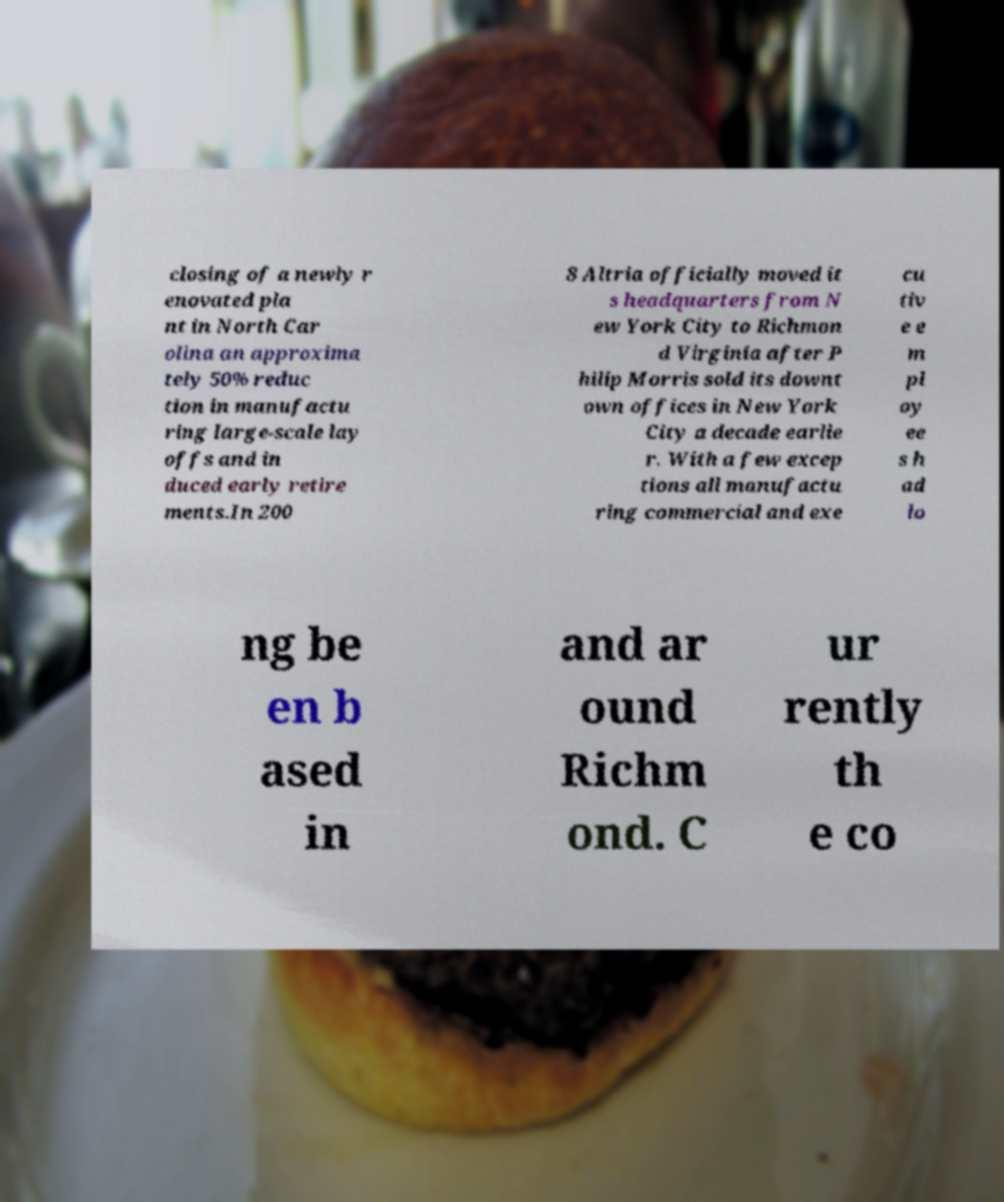What messages or text are displayed in this image? I need them in a readable, typed format. closing of a newly r enovated pla nt in North Car olina an approxima tely 50% reduc tion in manufactu ring large-scale lay offs and in duced early retire ments.In 200 8 Altria officially moved it s headquarters from N ew York City to Richmon d Virginia after P hilip Morris sold its downt own offices in New York City a decade earlie r. With a few excep tions all manufactu ring commercial and exe cu tiv e e m pl oy ee s h ad lo ng be en b ased in and ar ound Richm ond. C ur rently th e co 